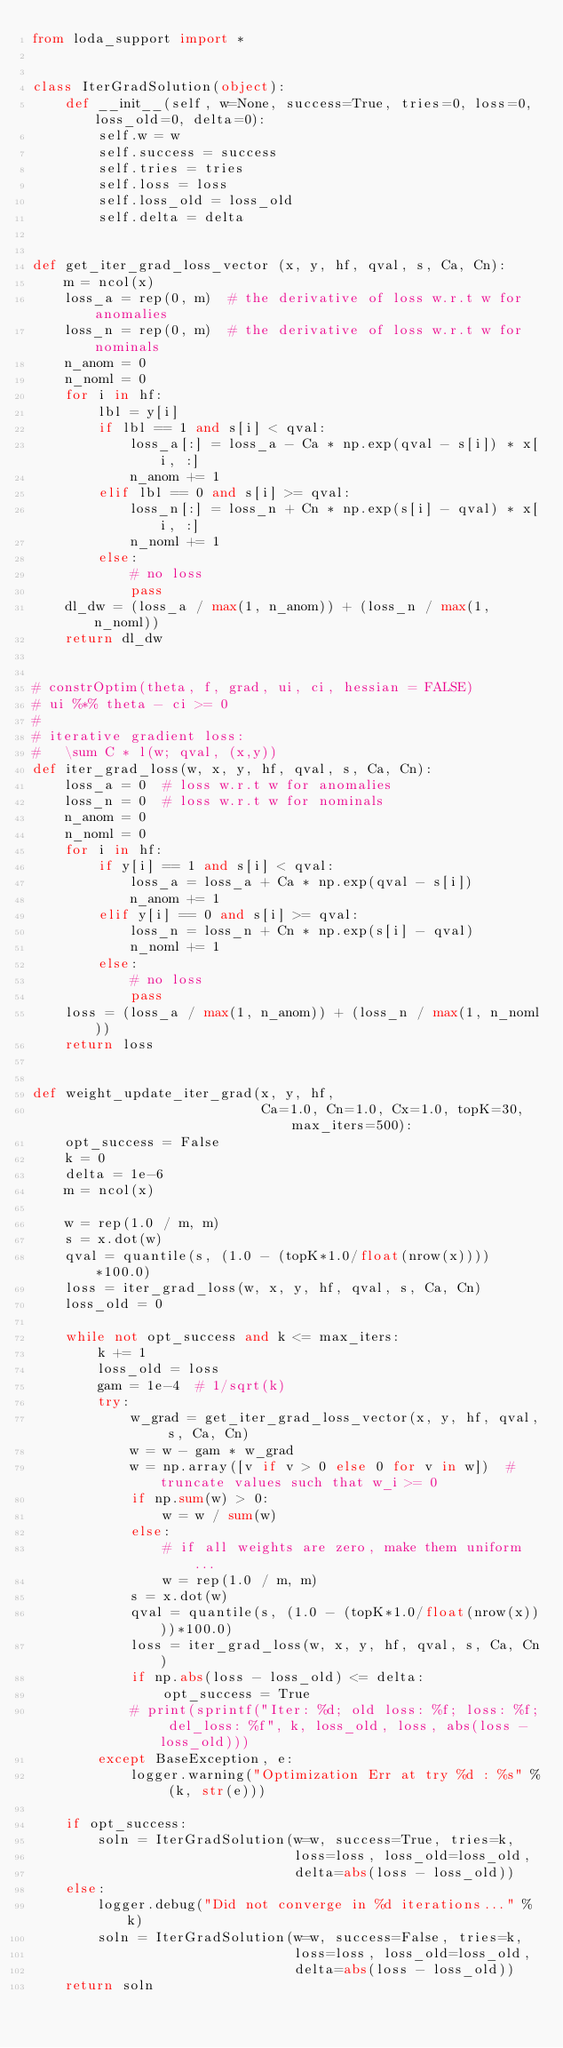Convert code to text. <code><loc_0><loc_0><loc_500><loc_500><_Python_>from loda_support import *


class IterGradSolution(object):
    def __init__(self, w=None, success=True, tries=0, loss=0, loss_old=0, delta=0):
        self.w = w
        self.success = success
        self.tries = tries
        self.loss = loss
        self.loss_old = loss_old
        self.delta = delta


def get_iter_grad_loss_vector (x, y, hf, qval, s, Ca, Cn):
    m = ncol(x)
    loss_a = rep(0, m)  # the derivative of loss w.r.t w for anomalies
    loss_n = rep(0, m)  # the derivative of loss w.r.t w for nominals
    n_anom = 0
    n_noml = 0
    for i in hf:
        lbl = y[i]
        if lbl == 1 and s[i] < qval:
            loss_a[:] = loss_a - Ca * np.exp(qval - s[i]) * x[i, :]
            n_anom += 1
        elif lbl == 0 and s[i] >= qval:
            loss_n[:] = loss_n + Cn * np.exp(s[i] - qval) * x[i, :]
            n_noml += 1
        else:
            # no loss
            pass
    dl_dw = (loss_a / max(1, n_anom)) + (loss_n / max(1, n_noml))
    return dl_dw


# constrOptim(theta, f, grad, ui, ci, hessian = FALSE)
# ui %*% theta - ci >= 0
#
# iterative gradient loss:
#   \sum C * l(w; qval, (x,y))
def iter_grad_loss(w, x, y, hf, qval, s, Ca, Cn):
    loss_a = 0  # loss w.r.t w for anomalies
    loss_n = 0  # loss w.r.t w for nominals
    n_anom = 0
    n_noml = 0
    for i in hf:
        if y[i] == 1 and s[i] < qval:
            loss_a = loss_a + Ca * np.exp(qval - s[i])
            n_anom += 1
        elif y[i] == 0 and s[i] >= qval:
            loss_n = loss_n + Cn * np.exp(s[i] - qval)
            n_noml += 1
        else:
            # no loss
            pass
    loss = (loss_a / max(1, n_anom)) + (loss_n / max(1, n_noml))
    return loss


def weight_update_iter_grad(x, y, hf,
                            Ca=1.0, Cn=1.0, Cx=1.0, topK=30, max_iters=500):
    opt_success = False
    k = 0
    delta = 1e-6
    m = ncol(x)

    w = rep(1.0 / m, m)
    s = x.dot(w)
    qval = quantile(s, (1.0 - (topK*1.0/float(nrow(x))))*100.0)
    loss = iter_grad_loss(w, x, y, hf, qval, s, Ca, Cn)
    loss_old = 0

    while not opt_success and k <= max_iters:
        k += 1
        loss_old = loss
        gam = 1e-4  # 1/sqrt(k)
        try:
            w_grad = get_iter_grad_loss_vector(x, y, hf, qval, s, Ca, Cn)
            w = w - gam * w_grad
            w = np.array([v if v > 0 else 0 for v in w])  # truncate values such that w_i >= 0
            if np.sum(w) > 0:
                w = w / sum(w)
            else:
                # if all weights are zero, make them uniform ...
                w = rep(1.0 / m, m)
            s = x.dot(w)
            qval = quantile(s, (1.0 - (topK*1.0/float(nrow(x))))*100.0)
            loss = iter_grad_loss(w, x, y, hf, qval, s, Ca, Cn)
            if np.abs(loss - loss_old) <= delta:
                opt_success = True
            # print(sprintf("Iter: %d; old loss: %f; loss: %f; del_loss: %f", k, loss_old, loss, abs(loss - loss_old)))
        except BaseException, e:
            logger.warning("Optimization Err at try %d : %s" % (k, str(e)))

    if opt_success:
        soln = IterGradSolution(w=w, success=True, tries=k,
                                loss=loss, loss_old=loss_old,
                                delta=abs(loss - loss_old))
    else:
        logger.debug("Did not converge in %d iterations..." % k)
        soln = IterGradSolution(w=w, success=False, tries=k,
                                loss=loss, loss_old=loss_old,
                                delta=abs(loss - loss_old))
    return soln
</code> 